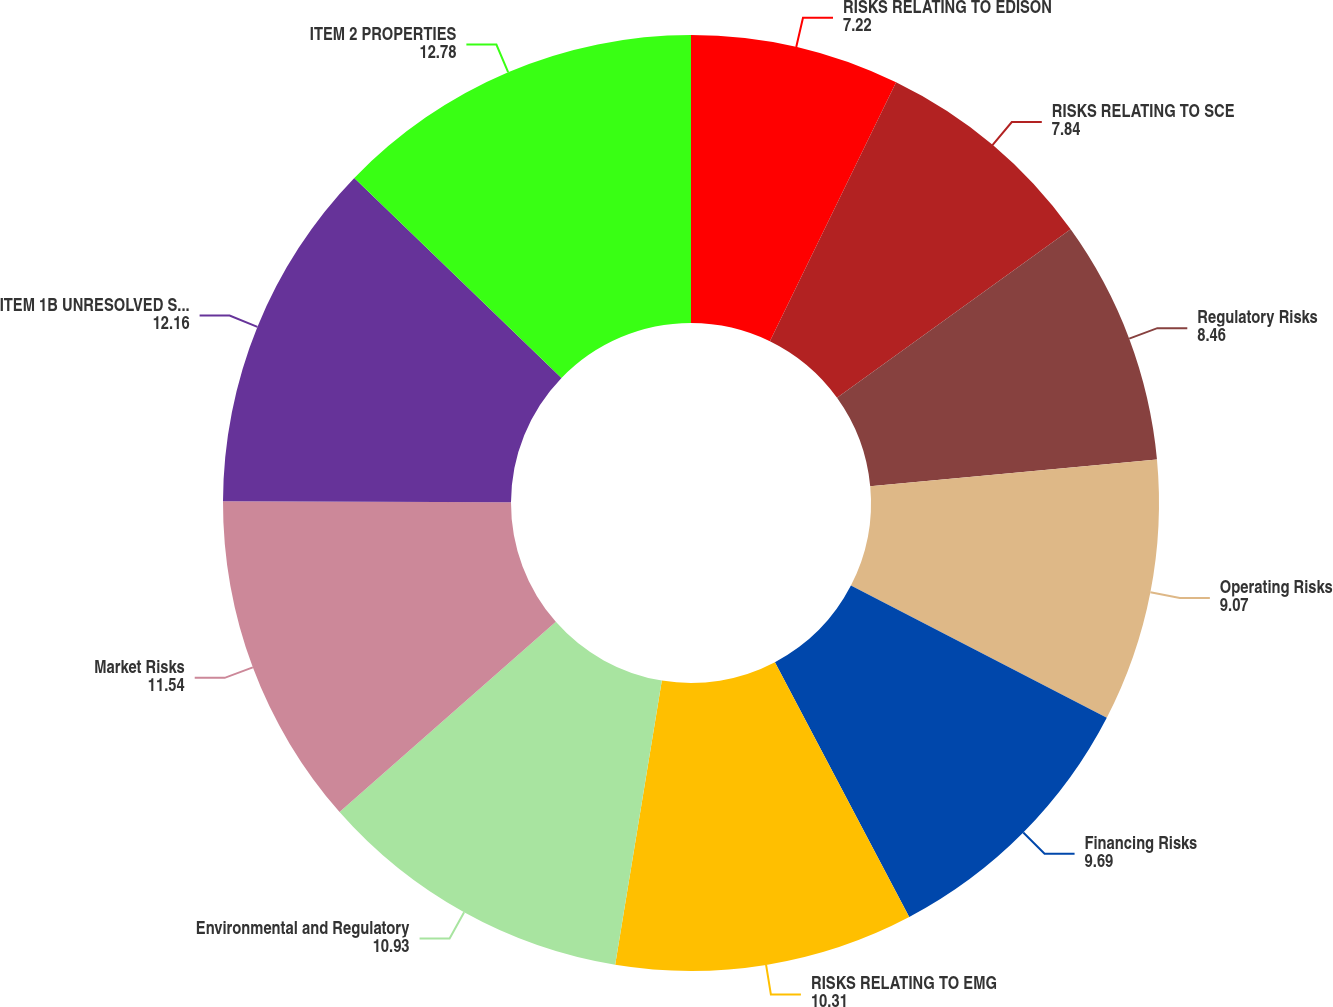Convert chart to OTSL. <chart><loc_0><loc_0><loc_500><loc_500><pie_chart><fcel>RISKS RELATING TO EDISON<fcel>RISKS RELATING TO SCE<fcel>Regulatory Risks<fcel>Operating Risks<fcel>Financing Risks<fcel>RISKS RELATING TO EMG<fcel>Environmental and Regulatory<fcel>Market Risks<fcel>ITEM 1B UNRESOLVED STAFF<fcel>ITEM 2 PROPERTIES<nl><fcel>7.22%<fcel>7.84%<fcel>8.46%<fcel>9.07%<fcel>9.69%<fcel>10.31%<fcel>10.93%<fcel>11.54%<fcel>12.16%<fcel>12.78%<nl></chart> 